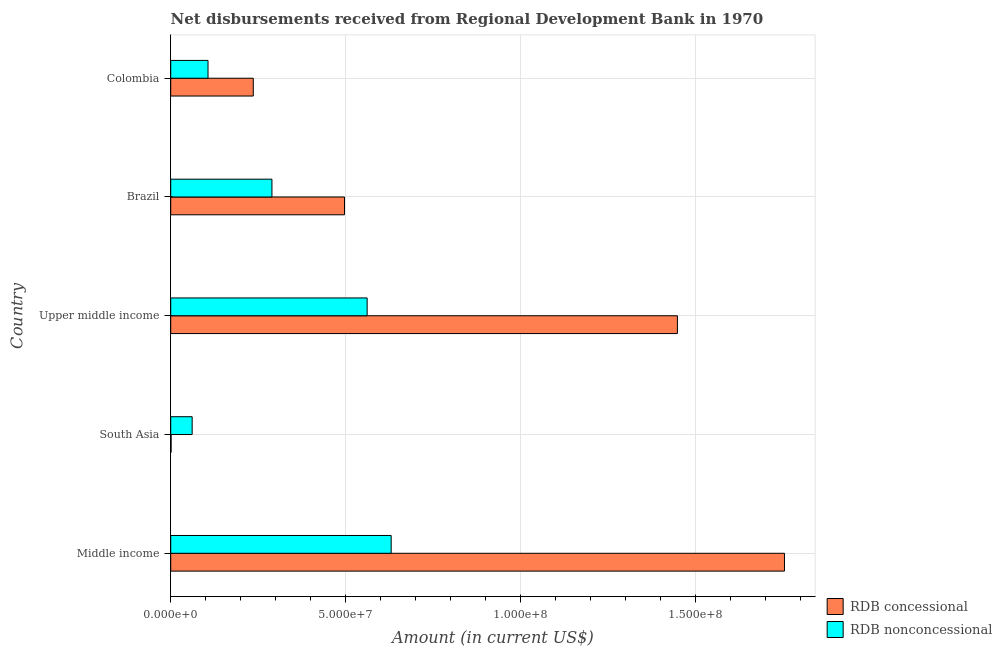How many groups of bars are there?
Your answer should be very brief. 5. How many bars are there on the 1st tick from the top?
Offer a very short reply. 2. What is the net non concessional disbursements from rdb in Upper middle income?
Provide a succinct answer. 5.62e+07. Across all countries, what is the maximum net non concessional disbursements from rdb?
Offer a very short reply. 6.31e+07. Across all countries, what is the minimum net concessional disbursements from rdb?
Provide a succinct answer. 1.09e+05. In which country was the net non concessional disbursements from rdb maximum?
Give a very brief answer. Middle income. In which country was the net concessional disbursements from rdb minimum?
Offer a very short reply. South Asia. What is the total net non concessional disbursements from rdb in the graph?
Make the answer very short. 1.65e+08. What is the difference between the net concessional disbursements from rdb in Middle income and that in South Asia?
Your answer should be very brief. 1.75e+08. What is the difference between the net non concessional disbursements from rdb in South Asia and the net concessional disbursements from rdb in Middle income?
Provide a succinct answer. -1.69e+08. What is the average net non concessional disbursements from rdb per country?
Ensure brevity in your answer.  3.30e+07. What is the difference between the net non concessional disbursements from rdb and net concessional disbursements from rdb in Colombia?
Provide a succinct answer. -1.29e+07. What is the ratio of the net concessional disbursements from rdb in Colombia to that in Upper middle income?
Make the answer very short. 0.16. What is the difference between the highest and the second highest net non concessional disbursements from rdb?
Offer a very short reply. 6.87e+06. What is the difference between the highest and the lowest net non concessional disbursements from rdb?
Provide a short and direct response. 5.69e+07. In how many countries, is the net non concessional disbursements from rdb greater than the average net non concessional disbursements from rdb taken over all countries?
Your answer should be very brief. 2. What does the 1st bar from the top in South Asia represents?
Offer a very short reply. RDB nonconcessional. What does the 2nd bar from the bottom in Brazil represents?
Give a very brief answer. RDB nonconcessional. How many bars are there?
Keep it short and to the point. 10. Does the graph contain grids?
Keep it short and to the point. Yes. How are the legend labels stacked?
Your response must be concise. Vertical. What is the title of the graph?
Your answer should be very brief. Net disbursements received from Regional Development Bank in 1970. Does "Highest 10% of population" appear as one of the legend labels in the graph?
Offer a very short reply. No. What is the label or title of the Y-axis?
Offer a terse response. Country. What is the Amount (in current US$) in RDB concessional in Middle income?
Provide a short and direct response. 1.76e+08. What is the Amount (in current US$) in RDB nonconcessional in Middle income?
Make the answer very short. 6.31e+07. What is the Amount (in current US$) in RDB concessional in South Asia?
Your answer should be compact. 1.09e+05. What is the Amount (in current US$) in RDB nonconcessional in South Asia?
Ensure brevity in your answer.  6.13e+06. What is the Amount (in current US$) of RDB concessional in Upper middle income?
Give a very brief answer. 1.45e+08. What is the Amount (in current US$) of RDB nonconcessional in Upper middle income?
Make the answer very short. 5.62e+07. What is the Amount (in current US$) in RDB concessional in Brazil?
Ensure brevity in your answer.  4.97e+07. What is the Amount (in current US$) of RDB nonconcessional in Brazil?
Make the answer very short. 2.90e+07. What is the Amount (in current US$) in RDB concessional in Colombia?
Your response must be concise. 2.36e+07. What is the Amount (in current US$) in RDB nonconcessional in Colombia?
Provide a succinct answer. 1.07e+07. Across all countries, what is the maximum Amount (in current US$) in RDB concessional?
Offer a terse response. 1.76e+08. Across all countries, what is the maximum Amount (in current US$) of RDB nonconcessional?
Your answer should be compact. 6.31e+07. Across all countries, what is the minimum Amount (in current US$) of RDB concessional?
Make the answer very short. 1.09e+05. Across all countries, what is the minimum Amount (in current US$) in RDB nonconcessional?
Make the answer very short. 6.13e+06. What is the total Amount (in current US$) of RDB concessional in the graph?
Make the answer very short. 3.94e+08. What is the total Amount (in current US$) of RDB nonconcessional in the graph?
Ensure brevity in your answer.  1.65e+08. What is the difference between the Amount (in current US$) in RDB concessional in Middle income and that in South Asia?
Provide a succinct answer. 1.75e+08. What is the difference between the Amount (in current US$) in RDB nonconcessional in Middle income and that in South Asia?
Keep it short and to the point. 5.69e+07. What is the difference between the Amount (in current US$) of RDB concessional in Middle income and that in Upper middle income?
Your answer should be compact. 3.06e+07. What is the difference between the Amount (in current US$) in RDB nonconcessional in Middle income and that in Upper middle income?
Make the answer very short. 6.87e+06. What is the difference between the Amount (in current US$) of RDB concessional in Middle income and that in Brazil?
Give a very brief answer. 1.26e+08. What is the difference between the Amount (in current US$) in RDB nonconcessional in Middle income and that in Brazil?
Give a very brief answer. 3.41e+07. What is the difference between the Amount (in current US$) in RDB concessional in Middle income and that in Colombia?
Provide a short and direct response. 1.52e+08. What is the difference between the Amount (in current US$) in RDB nonconcessional in Middle income and that in Colombia?
Provide a succinct answer. 5.24e+07. What is the difference between the Amount (in current US$) of RDB concessional in South Asia and that in Upper middle income?
Provide a succinct answer. -1.45e+08. What is the difference between the Amount (in current US$) in RDB nonconcessional in South Asia and that in Upper middle income?
Your response must be concise. -5.01e+07. What is the difference between the Amount (in current US$) of RDB concessional in South Asia and that in Brazil?
Provide a short and direct response. -4.96e+07. What is the difference between the Amount (in current US$) of RDB nonconcessional in South Asia and that in Brazil?
Offer a very short reply. -2.28e+07. What is the difference between the Amount (in current US$) of RDB concessional in South Asia and that in Colombia?
Make the answer very short. -2.35e+07. What is the difference between the Amount (in current US$) of RDB nonconcessional in South Asia and that in Colombia?
Make the answer very short. -4.54e+06. What is the difference between the Amount (in current US$) in RDB concessional in Upper middle income and that in Brazil?
Provide a succinct answer. 9.52e+07. What is the difference between the Amount (in current US$) of RDB nonconcessional in Upper middle income and that in Brazil?
Offer a very short reply. 2.72e+07. What is the difference between the Amount (in current US$) of RDB concessional in Upper middle income and that in Colombia?
Your answer should be compact. 1.21e+08. What is the difference between the Amount (in current US$) of RDB nonconcessional in Upper middle income and that in Colombia?
Your answer should be very brief. 4.55e+07. What is the difference between the Amount (in current US$) of RDB concessional in Brazil and that in Colombia?
Your answer should be compact. 2.61e+07. What is the difference between the Amount (in current US$) of RDB nonconcessional in Brazil and that in Colombia?
Offer a very short reply. 1.83e+07. What is the difference between the Amount (in current US$) of RDB concessional in Middle income and the Amount (in current US$) of RDB nonconcessional in South Asia?
Make the answer very short. 1.69e+08. What is the difference between the Amount (in current US$) in RDB concessional in Middle income and the Amount (in current US$) in RDB nonconcessional in Upper middle income?
Your answer should be compact. 1.19e+08. What is the difference between the Amount (in current US$) of RDB concessional in Middle income and the Amount (in current US$) of RDB nonconcessional in Brazil?
Give a very brief answer. 1.47e+08. What is the difference between the Amount (in current US$) of RDB concessional in Middle income and the Amount (in current US$) of RDB nonconcessional in Colombia?
Your answer should be compact. 1.65e+08. What is the difference between the Amount (in current US$) of RDB concessional in South Asia and the Amount (in current US$) of RDB nonconcessional in Upper middle income?
Your answer should be compact. -5.61e+07. What is the difference between the Amount (in current US$) in RDB concessional in South Asia and the Amount (in current US$) in RDB nonconcessional in Brazil?
Keep it short and to the point. -2.88e+07. What is the difference between the Amount (in current US$) of RDB concessional in South Asia and the Amount (in current US$) of RDB nonconcessional in Colombia?
Your answer should be very brief. -1.06e+07. What is the difference between the Amount (in current US$) of RDB concessional in Upper middle income and the Amount (in current US$) of RDB nonconcessional in Brazil?
Make the answer very short. 1.16e+08. What is the difference between the Amount (in current US$) in RDB concessional in Upper middle income and the Amount (in current US$) in RDB nonconcessional in Colombia?
Your response must be concise. 1.34e+08. What is the difference between the Amount (in current US$) of RDB concessional in Brazil and the Amount (in current US$) of RDB nonconcessional in Colombia?
Ensure brevity in your answer.  3.90e+07. What is the average Amount (in current US$) in RDB concessional per country?
Provide a succinct answer. 7.88e+07. What is the average Amount (in current US$) of RDB nonconcessional per country?
Offer a terse response. 3.30e+07. What is the difference between the Amount (in current US$) of RDB concessional and Amount (in current US$) of RDB nonconcessional in Middle income?
Your response must be concise. 1.12e+08. What is the difference between the Amount (in current US$) in RDB concessional and Amount (in current US$) in RDB nonconcessional in South Asia?
Provide a succinct answer. -6.02e+06. What is the difference between the Amount (in current US$) in RDB concessional and Amount (in current US$) in RDB nonconcessional in Upper middle income?
Keep it short and to the point. 8.87e+07. What is the difference between the Amount (in current US$) of RDB concessional and Amount (in current US$) of RDB nonconcessional in Brazil?
Make the answer very short. 2.08e+07. What is the difference between the Amount (in current US$) in RDB concessional and Amount (in current US$) in RDB nonconcessional in Colombia?
Your answer should be compact. 1.29e+07. What is the ratio of the Amount (in current US$) in RDB concessional in Middle income to that in South Asia?
Your answer should be compact. 1610.58. What is the ratio of the Amount (in current US$) of RDB nonconcessional in Middle income to that in South Asia?
Your answer should be compact. 10.28. What is the ratio of the Amount (in current US$) in RDB concessional in Middle income to that in Upper middle income?
Your answer should be very brief. 1.21. What is the ratio of the Amount (in current US$) of RDB nonconcessional in Middle income to that in Upper middle income?
Offer a terse response. 1.12. What is the ratio of the Amount (in current US$) in RDB concessional in Middle income to that in Brazil?
Your response must be concise. 3.53. What is the ratio of the Amount (in current US$) of RDB nonconcessional in Middle income to that in Brazil?
Provide a short and direct response. 2.18. What is the ratio of the Amount (in current US$) of RDB concessional in Middle income to that in Colombia?
Keep it short and to the point. 7.43. What is the ratio of the Amount (in current US$) in RDB nonconcessional in Middle income to that in Colombia?
Provide a short and direct response. 5.91. What is the ratio of the Amount (in current US$) in RDB concessional in South Asia to that in Upper middle income?
Ensure brevity in your answer.  0. What is the ratio of the Amount (in current US$) in RDB nonconcessional in South Asia to that in Upper middle income?
Provide a short and direct response. 0.11. What is the ratio of the Amount (in current US$) in RDB concessional in South Asia to that in Brazil?
Offer a terse response. 0. What is the ratio of the Amount (in current US$) in RDB nonconcessional in South Asia to that in Brazil?
Keep it short and to the point. 0.21. What is the ratio of the Amount (in current US$) of RDB concessional in South Asia to that in Colombia?
Provide a short and direct response. 0. What is the ratio of the Amount (in current US$) of RDB nonconcessional in South Asia to that in Colombia?
Your answer should be very brief. 0.57. What is the ratio of the Amount (in current US$) in RDB concessional in Upper middle income to that in Brazil?
Keep it short and to the point. 2.92. What is the ratio of the Amount (in current US$) of RDB nonconcessional in Upper middle income to that in Brazil?
Offer a very short reply. 1.94. What is the ratio of the Amount (in current US$) in RDB concessional in Upper middle income to that in Colombia?
Your response must be concise. 6.14. What is the ratio of the Amount (in current US$) of RDB nonconcessional in Upper middle income to that in Colombia?
Your answer should be very brief. 5.27. What is the ratio of the Amount (in current US$) of RDB concessional in Brazil to that in Colombia?
Keep it short and to the point. 2.1. What is the ratio of the Amount (in current US$) of RDB nonconcessional in Brazil to that in Colombia?
Offer a very short reply. 2.71. What is the difference between the highest and the second highest Amount (in current US$) of RDB concessional?
Make the answer very short. 3.06e+07. What is the difference between the highest and the second highest Amount (in current US$) in RDB nonconcessional?
Your response must be concise. 6.87e+06. What is the difference between the highest and the lowest Amount (in current US$) in RDB concessional?
Make the answer very short. 1.75e+08. What is the difference between the highest and the lowest Amount (in current US$) of RDB nonconcessional?
Make the answer very short. 5.69e+07. 